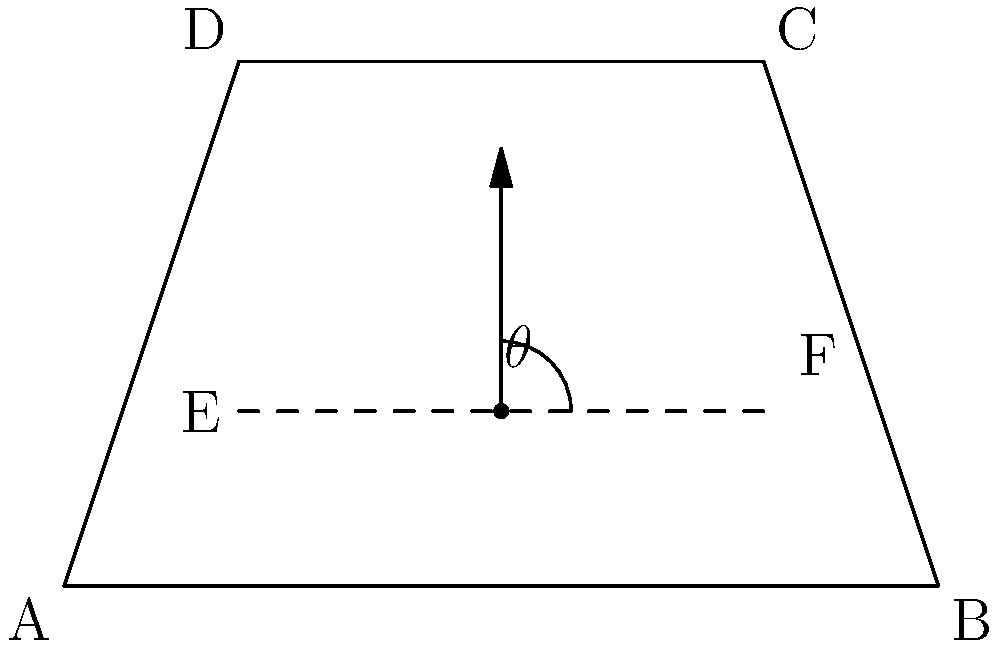In a trapezoidal room ABCD, sound-absorbing panels are to be installed along the line EF. To maximize sound absorption, the panels need to be tilted at an optimal angle $\theta$ from the vertical. Given that AB = 10m, DC = 6m, AD = 6m, and EF is positioned 2m above AB, calculate the optimal tilt angle $\theta$ (in degrees) for the panels. To find the optimal tilt angle, we need to determine the angle that is perpendicular to the sloping ceiling. This will ensure maximum sound reflection towards the absorbing panels.

Step 1: Find the slope of the ceiling (line BC).
- Rise = DC - AB = 6m - 10m = -4m
- Run = AD = 6m
- Slope of BC = -4/6 = -2/3

Step 2: Calculate the angle of the ceiling with respect to the horizontal.
$\alpha = \arctan(-2/3) \approx -33.69°$

Step 3: The optimal angle for the panels should be perpendicular to the ceiling slope. To achieve this, we need to add 90° to the ceiling angle.
$\theta = 90° + \alpha = 90° + (-33.69°) = 56.31°$

Step 4: However, we need the angle from the vertical, not the horizontal. To get this, we subtract our result from 90°.
$\theta_{vertical} = 90° - 56.31° = 33.69°$

Therefore, the optimal tilt angle for the panels from the vertical is approximately 33.69°.
Answer: $33.69°$ 